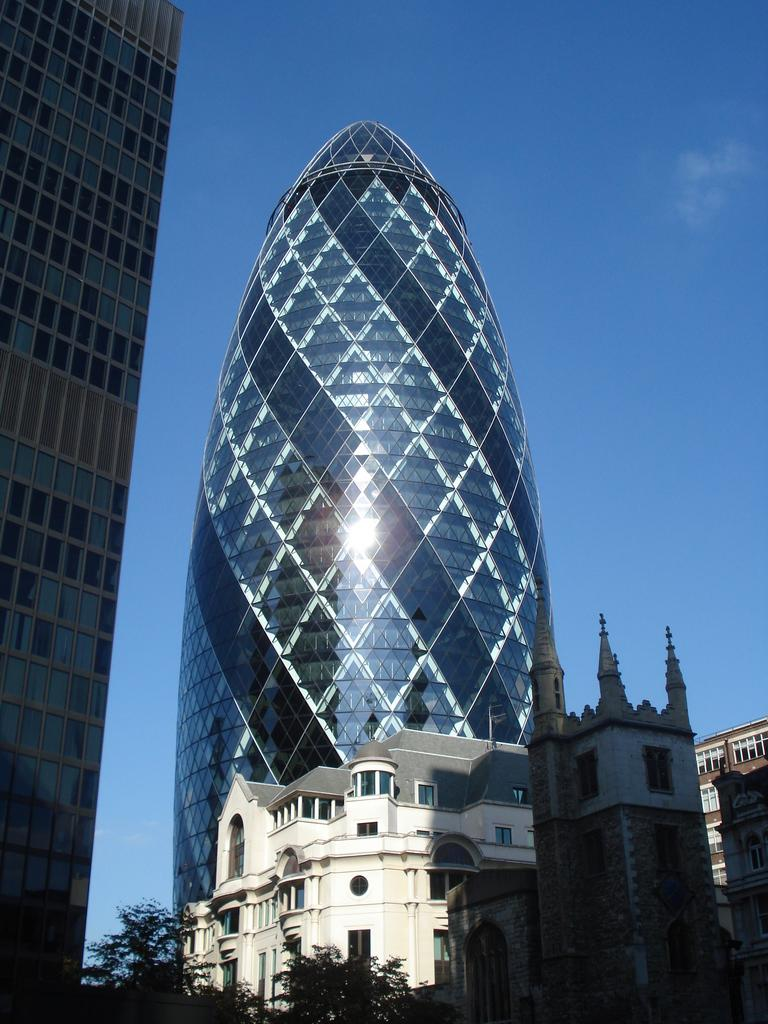What type of structures can be seen in the image? There are buildings in the image. What other natural elements are present in the image? There are trees in the image. What is visible at the top of the image? The sky is visible at the top of the image. What type of advice can be seen written on the trees in the image? There is no advice written on the trees in the image; it only features buildings, trees, and the sky. What flavor of pie is being served in the image? There is no pie present in the image. 